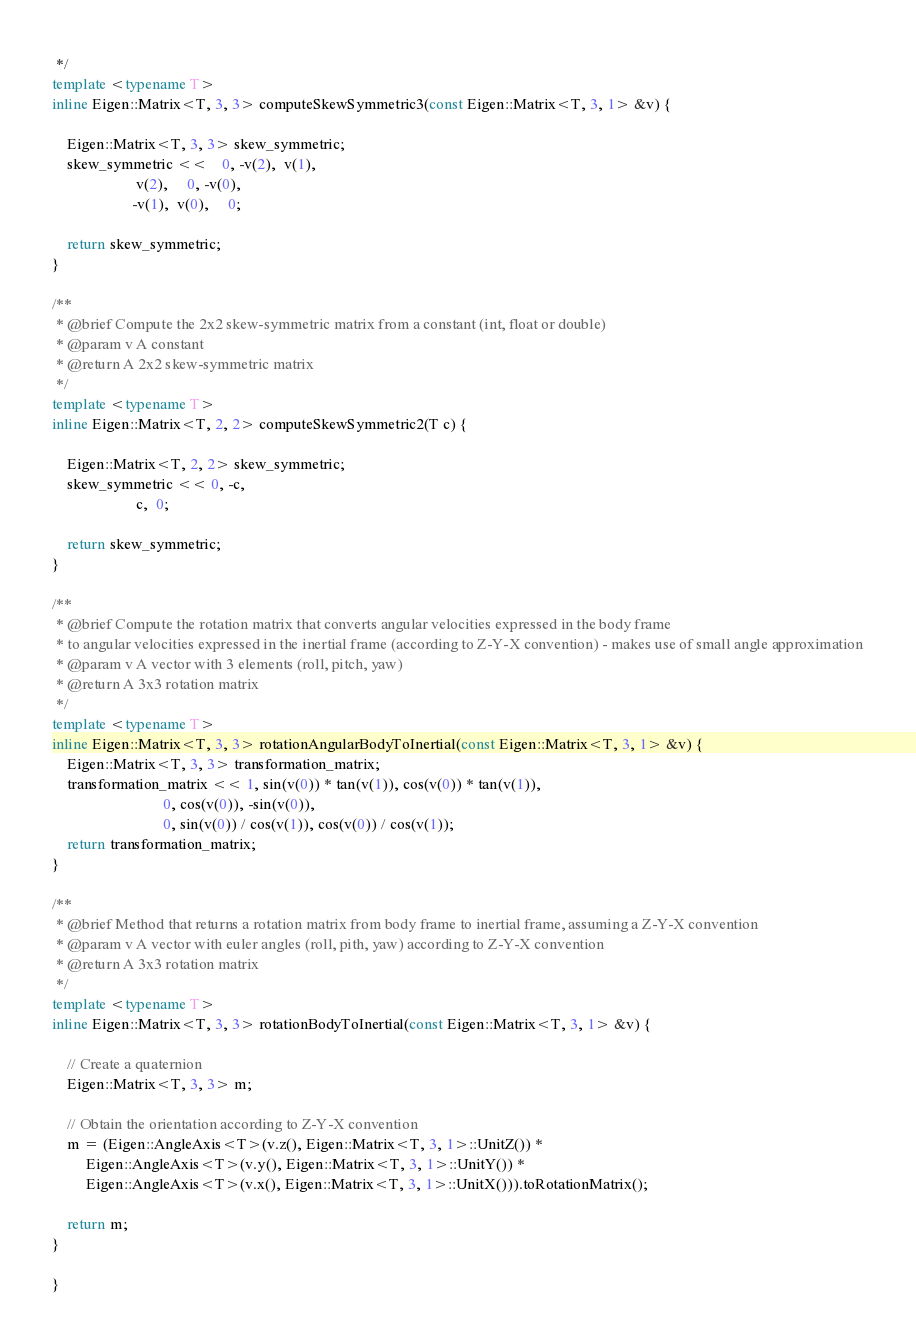Convert code to text. <code><loc_0><loc_0><loc_500><loc_500><_C++_> */
template <typename T>
inline Eigen::Matrix<T, 3, 3> computeSkewSymmetric3(const Eigen::Matrix<T, 3, 1> &v) {

    Eigen::Matrix<T, 3, 3> skew_symmetric;
    skew_symmetric <<    0, -v(2),  v(1),
                      v(2),     0, -v(0),
                     -v(1),  v(0),     0;

    return skew_symmetric;
}

/**
 * @brief Compute the 2x2 skew-symmetric matrix from a constant (int, float or double)
 * @param v A constant
 * @return A 2x2 skew-symmetric matrix
 */
template <typename T>
inline Eigen::Matrix<T, 2, 2> computeSkewSymmetric2(T c) {

    Eigen::Matrix<T, 2, 2> skew_symmetric;
    skew_symmetric << 0, -c,
                      c,  0;

    return skew_symmetric;
}

/**
 * @brief Compute the rotation matrix that converts angular velocities expressed in the body frame
 * to angular velocities expressed in the inertial frame (according to Z-Y-X convention) - makes use of small angle approximation
 * @param v A vector with 3 elements (roll, pitch, yaw)
 * @return A 3x3 rotation matrix
 */
template <typename T>
inline Eigen::Matrix<T, 3, 3> rotationAngularBodyToInertial(const Eigen::Matrix<T, 3, 1> &v) {
    Eigen::Matrix<T, 3, 3> transformation_matrix;
    transformation_matrix << 1, sin(v(0)) * tan(v(1)), cos(v(0)) * tan(v(1)),
                             0, cos(v(0)), -sin(v(0)),
                             0, sin(v(0)) / cos(v(1)), cos(v(0)) / cos(v(1));
    return transformation_matrix;
}

/**
 * @brief Method that returns a rotation matrix from body frame to inertial frame, assuming a Z-Y-X convention
 * @param v A vector with euler angles (roll, pith, yaw) according to Z-Y-X convention
 * @return A 3x3 rotation matrix
 */
template <typename T>
inline Eigen::Matrix<T, 3, 3> rotationBodyToInertial(const Eigen::Matrix<T, 3, 1> &v) {
    
    // Create a quaternion
    Eigen::Matrix<T, 3, 3> m;

    // Obtain the orientation according to Z-Y-X convention
    m = (Eigen::AngleAxis<T>(v.z(), Eigen::Matrix<T, 3, 1>::UnitZ()) *
         Eigen::AngleAxis<T>(v.y(), Eigen::Matrix<T, 3, 1>::UnitY()) *
         Eigen::AngleAxis<T>(v.x(), Eigen::Matrix<T, 3, 1>::UnitX())).toRotationMatrix();
    
    return m;
}

}</code> 